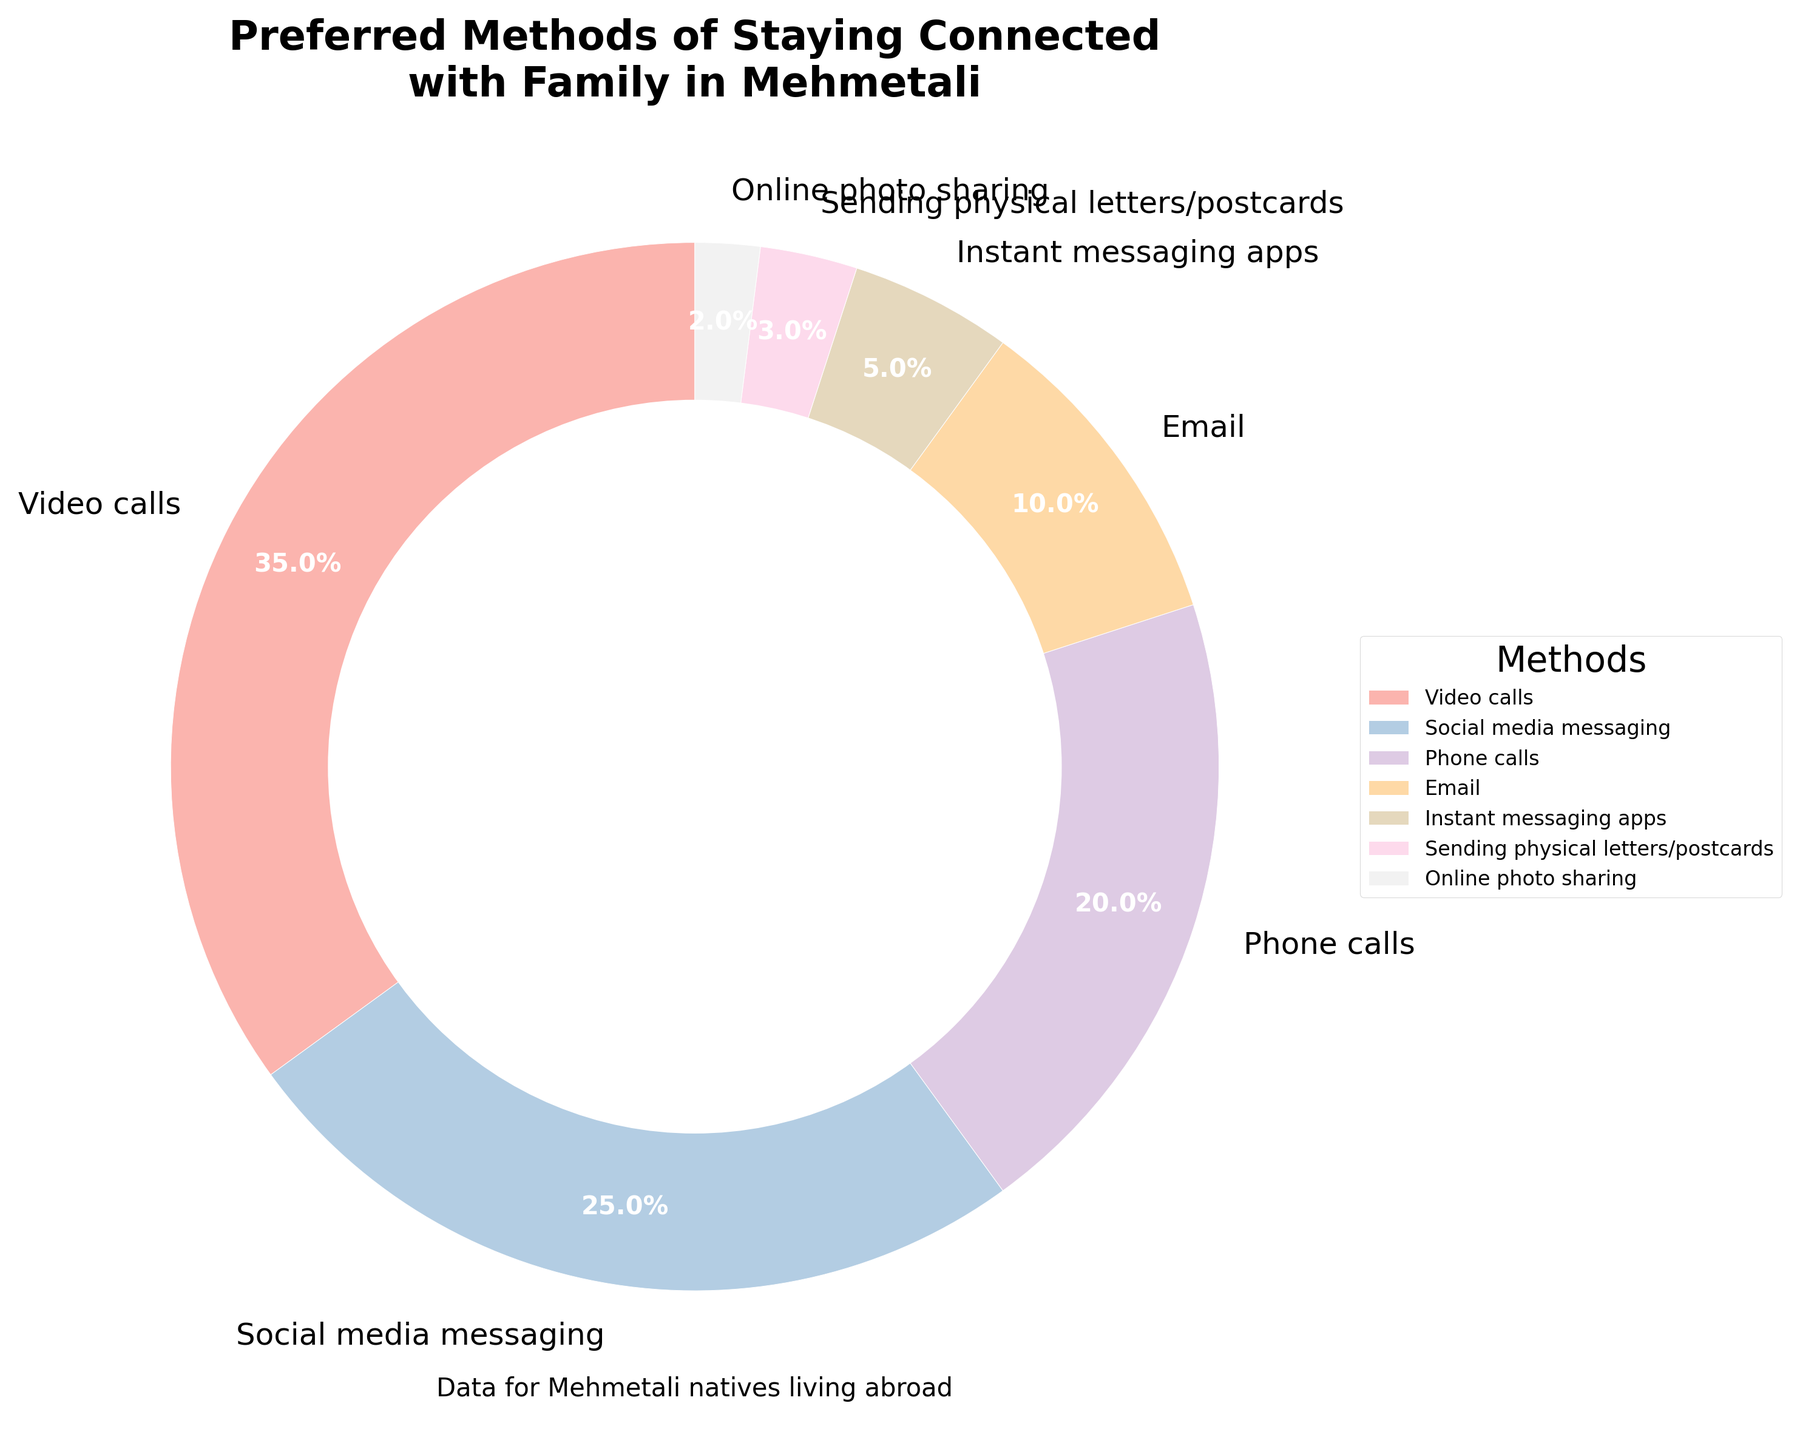Which communication method is preferred the most by Mehmetali natives living abroad? Video calls have the largest portion of the pie chart at 35%, which is greater than any other category.
Answer: Video calls What is the combined percentage of Social media messaging and Phone calls? Social media messaging is 25% and Phone calls are 20%. Adding them together gives us 25% + 20% = 45%.
Answer: 45% How much more preferred are Video calls compared to Email? Video calls have a 35% preference while Email has 10%. The difference is 35% - 10% = 25%.
Answer: 25% Which method is the least preferred, and what is its percentage? Online photo sharing has the smallest segment in the pie chart with a percentage of 2%.
Answer: Online photo sharing, 2% What is the total percentage of methods that are not based on instant communication? Non-instant communication methods include Email (10%), Sending physical letters/postcards (3%), and Online photo sharing (2%). Summing these gives us 10% + 3% + 2% = 15%.
Answer: 15% Is the percentage of Social media messaging greater than Phone calls and Email combined? The percentage for Social media messaging is 25%, while Phone calls and Email combined is 20% + 10% = 30%. 25% is less than 30%.
Answer: No By how much percent does the preference for Instant messaging apps differ from that for Sending physical letters/postcards? Instant messaging apps are at 5%, while Sending physical letters/postcards are at 3%. The difference is 5% - 3% = 2%.
Answer: 2% What is the average percentage of the least preferred three methods? The least preferred three methods are Sending physical letters/postcards (3%), Online photo sharing (2%), and Instant messaging apps (5%). Their total percentage is 3% + 2% + 5% = 10%. The average is 10% / 3 ≈ 3.33%.
Answer: 3.33% 